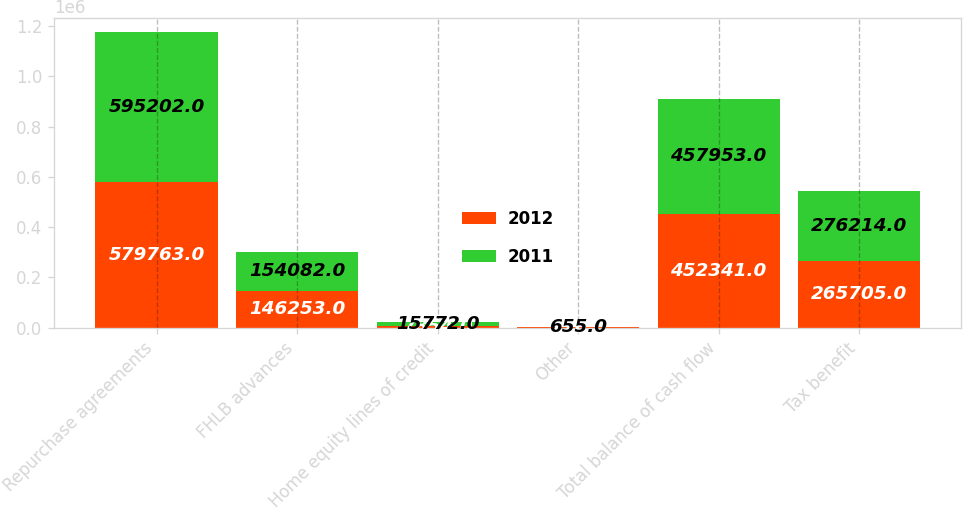<chart> <loc_0><loc_0><loc_500><loc_500><stacked_bar_chart><ecel><fcel>Repurchase agreements<fcel>FHLB advances<fcel>Home equity lines of credit<fcel>Other<fcel>Total balance of cash flow<fcel>Tax benefit<nl><fcel>2012<fcel>579763<fcel>146253<fcel>7854<fcel>116<fcel>452341<fcel>265705<nl><fcel>2011<fcel>595202<fcel>154082<fcel>15772<fcel>655<fcel>457953<fcel>276214<nl></chart> 